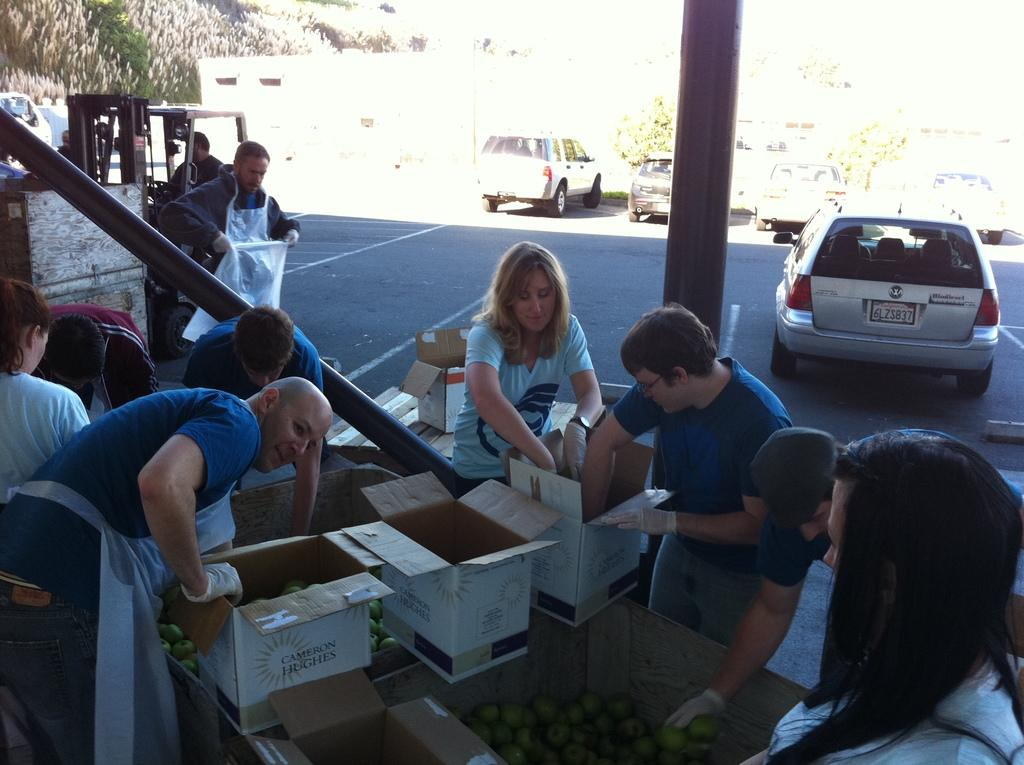What is the main subject in the middle of the image? There is a woman sitting in the middle of the image. What is the woman doing with her hands? The woman has her hands in a box. What can be seen on the right side of the image? There is a car on the right side of the image. Where is the car located? The car is on the road. Are there any other people in the image besides the woman? Yes, there are other people in the image. What type of food is being served at the zoo in the image? There is no zoo or food present in the image. What is the purpose of the coil in the image? There is no coil present in the image. 